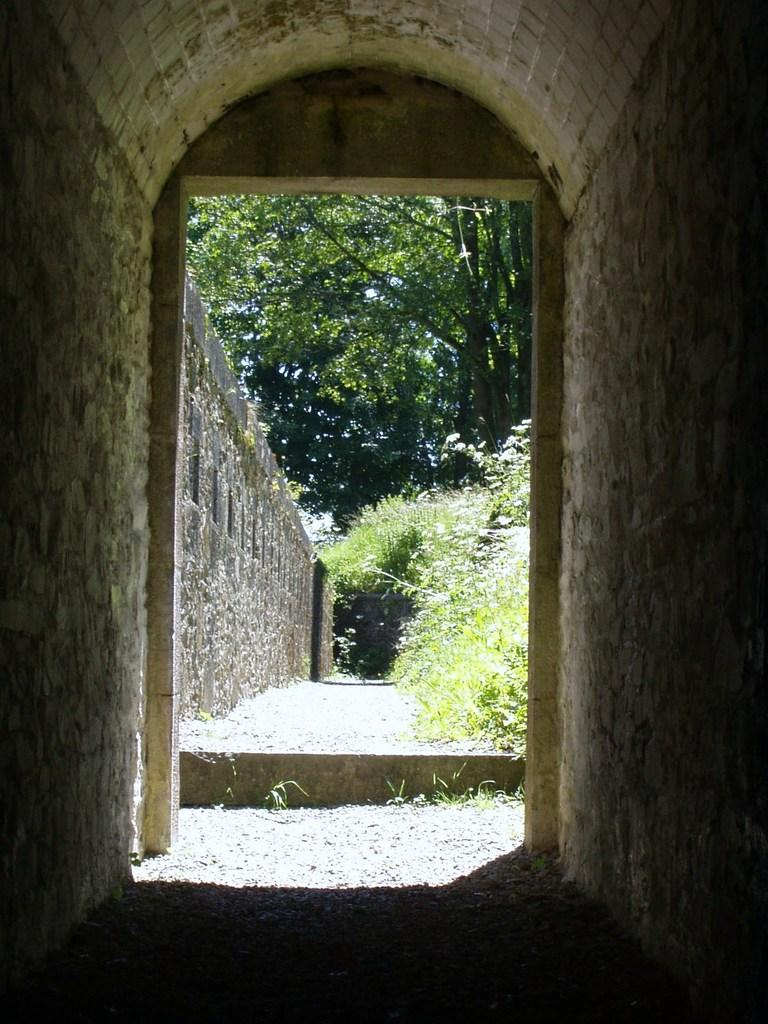What type of vegetation can be seen in the image? There are green color trees in the image. What else is present in the image besides the trees? There is a wall in the image. How many chickens are sitting on the soda can in the image? There are no chickens or soda cans present in the image. 